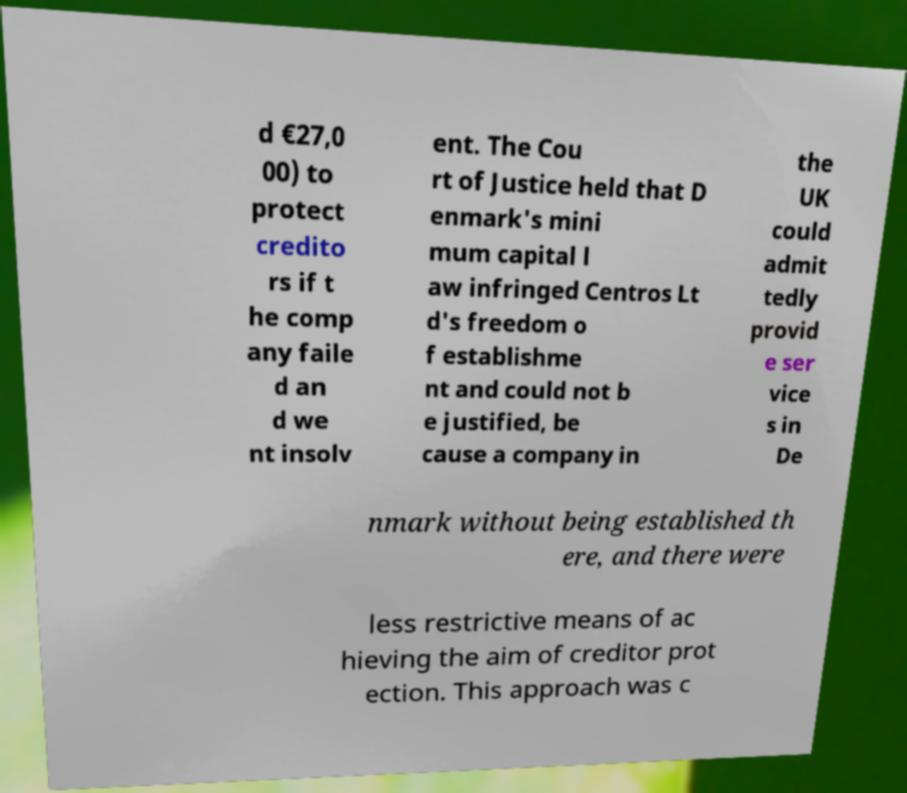Could you extract and type out the text from this image? d €27,0 00) to protect credito rs if t he comp any faile d an d we nt insolv ent. The Cou rt of Justice held that D enmark's mini mum capital l aw infringed Centros Lt d's freedom o f establishme nt and could not b e justified, be cause a company in the UK could admit tedly provid e ser vice s in De nmark without being established th ere, and there were less restrictive means of ac hieving the aim of creditor prot ection. This approach was c 